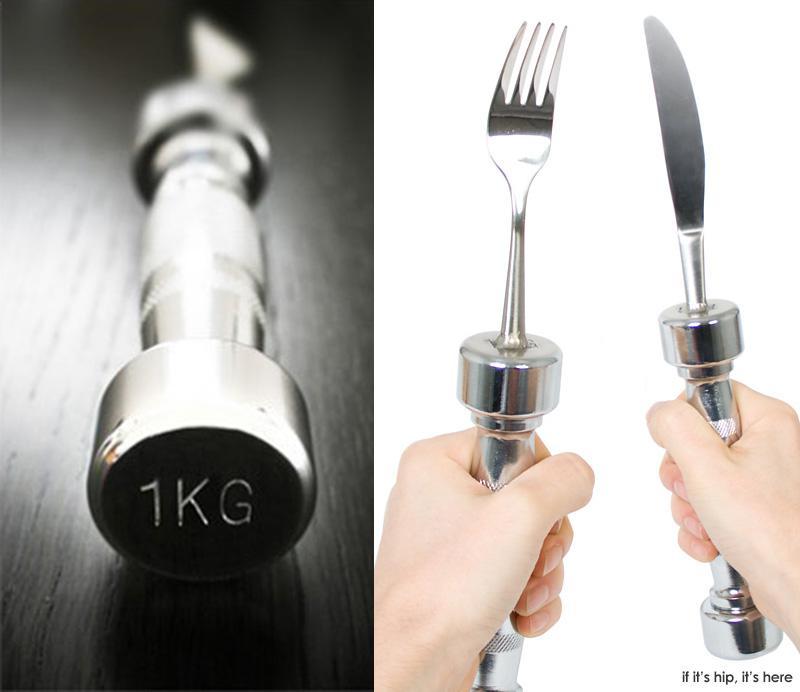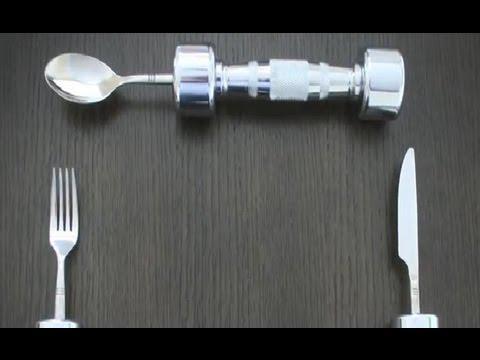The first image is the image on the left, the second image is the image on the right. Assess this claim about the two images: "There is a knife, fork, and spoon in the image on the right.". Correct or not? Answer yes or no. Yes. 